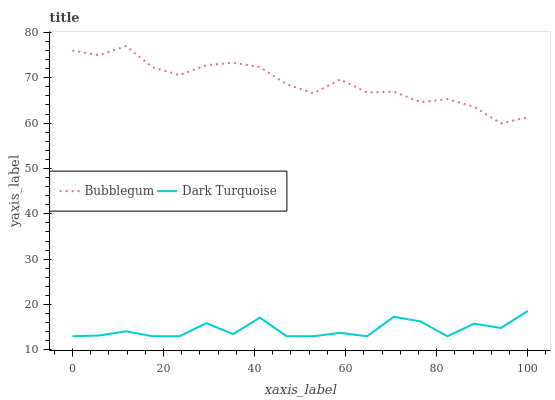Does Dark Turquoise have the minimum area under the curve?
Answer yes or no. Yes. Does Bubblegum have the maximum area under the curve?
Answer yes or no. Yes. Does Bubblegum have the minimum area under the curve?
Answer yes or no. No. Is Bubblegum the smoothest?
Answer yes or no. Yes. Is Dark Turquoise the roughest?
Answer yes or no. Yes. Is Bubblegum the roughest?
Answer yes or no. No. Does Bubblegum have the lowest value?
Answer yes or no. No. Does Bubblegum have the highest value?
Answer yes or no. Yes. Is Dark Turquoise less than Bubblegum?
Answer yes or no. Yes. Is Bubblegum greater than Dark Turquoise?
Answer yes or no. Yes. Does Dark Turquoise intersect Bubblegum?
Answer yes or no. No. 